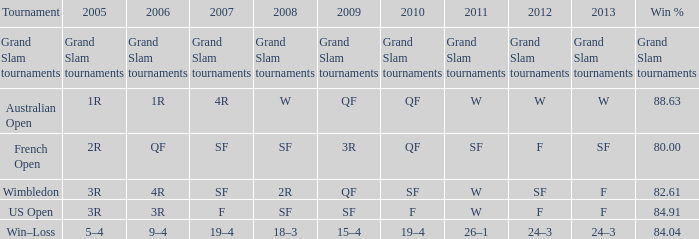In 2008, what was the value of "f" relating to 2007? SF. 